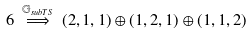Convert formula to latex. <formula><loc_0><loc_0><loc_500><loc_500>6 \, \stackrel { \mathbb { G } _ { s u b T S } } { \Longrightarrow } \, ( 2 , 1 , 1 ) \oplus ( 1 , 2 , 1 ) \oplus ( 1 , 1 , 2 )</formula> 